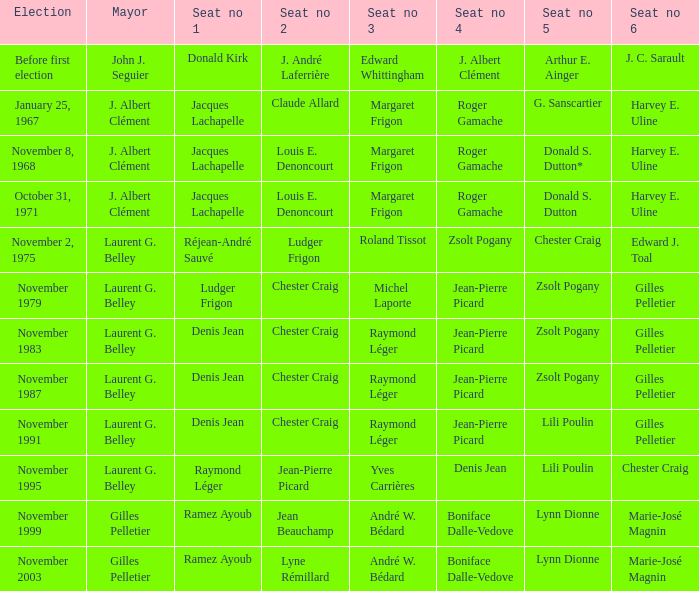Who was seat no 6 when seat no 1 and seat no 5 were jacques lachapelle and donald s. dutton Harvey E. Uline. 